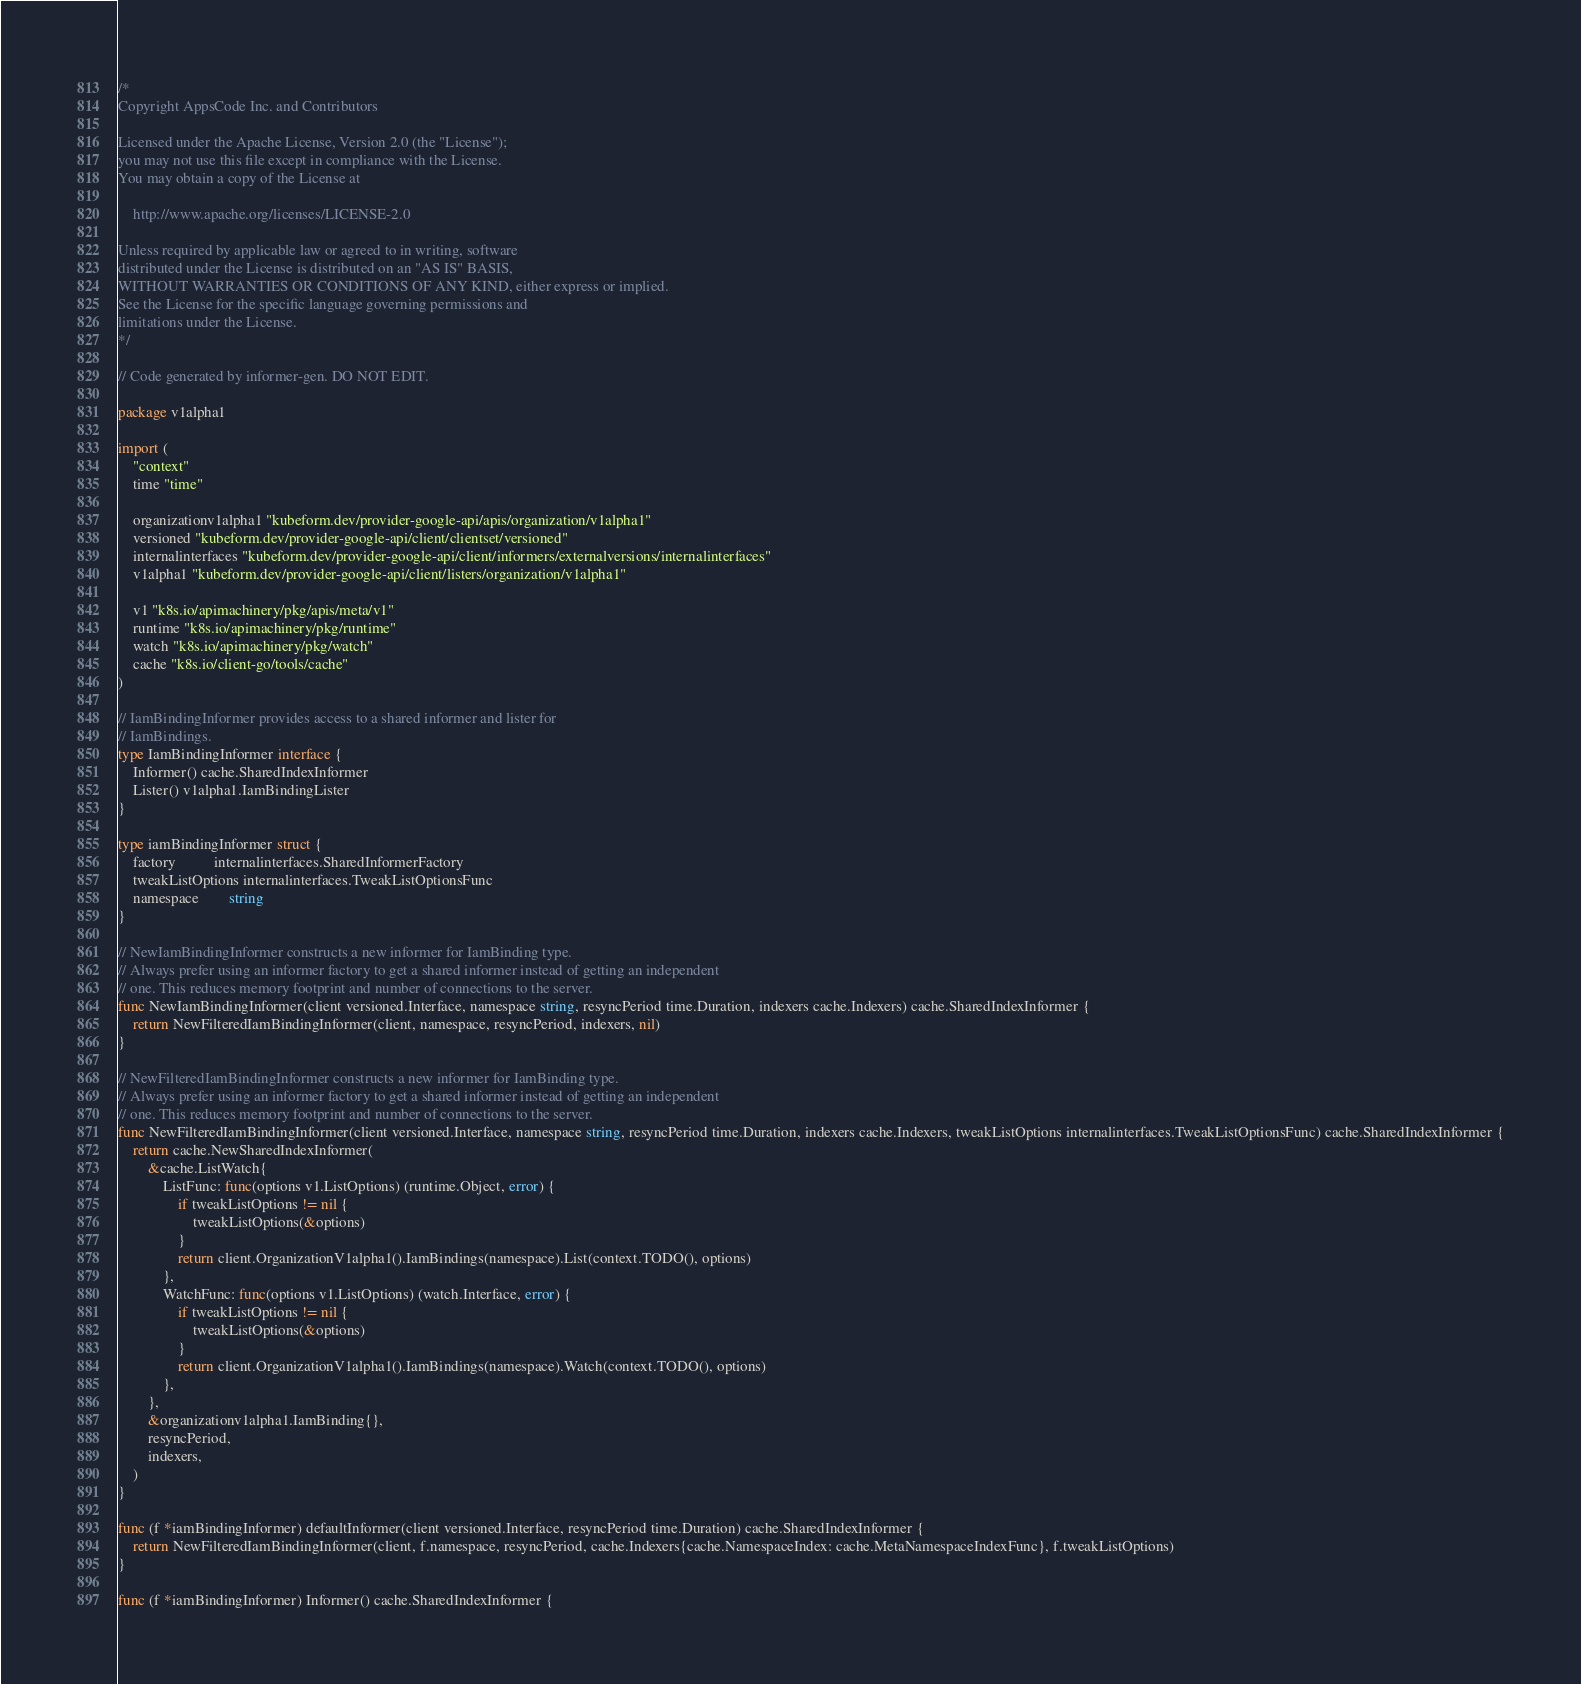Convert code to text. <code><loc_0><loc_0><loc_500><loc_500><_Go_>/*
Copyright AppsCode Inc. and Contributors

Licensed under the Apache License, Version 2.0 (the "License");
you may not use this file except in compliance with the License.
You may obtain a copy of the License at

    http://www.apache.org/licenses/LICENSE-2.0

Unless required by applicable law or agreed to in writing, software
distributed under the License is distributed on an "AS IS" BASIS,
WITHOUT WARRANTIES OR CONDITIONS OF ANY KIND, either express or implied.
See the License for the specific language governing permissions and
limitations under the License.
*/

// Code generated by informer-gen. DO NOT EDIT.

package v1alpha1

import (
	"context"
	time "time"

	organizationv1alpha1 "kubeform.dev/provider-google-api/apis/organization/v1alpha1"
	versioned "kubeform.dev/provider-google-api/client/clientset/versioned"
	internalinterfaces "kubeform.dev/provider-google-api/client/informers/externalversions/internalinterfaces"
	v1alpha1 "kubeform.dev/provider-google-api/client/listers/organization/v1alpha1"

	v1 "k8s.io/apimachinery/pkg/apis/meta/v1"
	runtime "k8s.io/apimachinery/pkg/runtime"
	watch "k8s.io/apimachinery/pkg/watch"
	cache "k8s.io/client-go/tools/cache"
)

// IamBindingInformer provides access to a shared informer and lister for
// IamBindings.
type IamBindingInformer interface {
	Informer() cache.SharedIndexInformer
	Lister() v1alpha1.IamBindingLister
}

type iamBindingInformer struct {
	factory          internalinterfaces.SharedInformerFactory
	tweakListOptions internalinterfaces.TweakListOptionsFunc
	namespace        string
}

// NewIamBindingInformer constructs a new informer for IamBinding type.
// Always prefer using an informer factory to get a shared informer instead of getting an independent
// one. This reduces memory footprint and number of connections to the server.
func NewIamBindingInformer(client versioned.Interface, namespace string, resyncPeriod time.Duration, indexers cache.Indexers) cache.SharedIndexInformer {
	return NewFilteredIamBindingInformer(client, namespace, resyncPeriod, indexers, nil)
}

// NewFilteredIamBindingInformer constructs a new informer for IamBinding type.
// Always prefer using an informer factory to get a shared informer instead of getting an independent
// one. This reduces memory footprint and number of connections to the server.
func NewFilteredIamBindingInformer(client versioned.Interface, namespace string, resyncPeriod time.Duration, indexers cache.Indexers, tweakListOptions internalinterfaces.TweakListOptionsFunc) cache.SharedIndexInformer {
	return cache.NewSharedIndexInformer(
		&cache.ListWatch{
			ListFunc: func(options v1.ListOptions) (runtime.Object, error) {
				if tweakListOptions != nil {
					tweakListOptions(&options)
				}
				return client.OrganizationV1alpha1().IamBindings(namespace).List(context.TODO(), options)
			},
			WatchFunc: func(options v1.ListOptions) (watch.Interface, error) {
				if tweakListOptions != nil {
					tweakListOptions(&options)
				}
				return client.OrganizationV1alpha1().IamBindings(namespace).Watch(context.TODO(), options)
			},
		},
		&organizationv1alpha1.IamBinding{},
		resyncPeriod,
		indexers,
	)
}

func (f *iamBindingInformer) defaultInformer(client versioned.Interface, resyncPeriod time.Duration) cache.SharedIndexInformer {
	return NewFilteredIamBindingInformer(client, f.namespace, resyncPeriod, cache.Indexers{cache.NamespaceIndex: cache.MetaNamespaceIndexFunc}, f.tweakListOptions)
}

func (f *iamBindingInformer) Informer() cache.SharedIndexInformer {</code> 